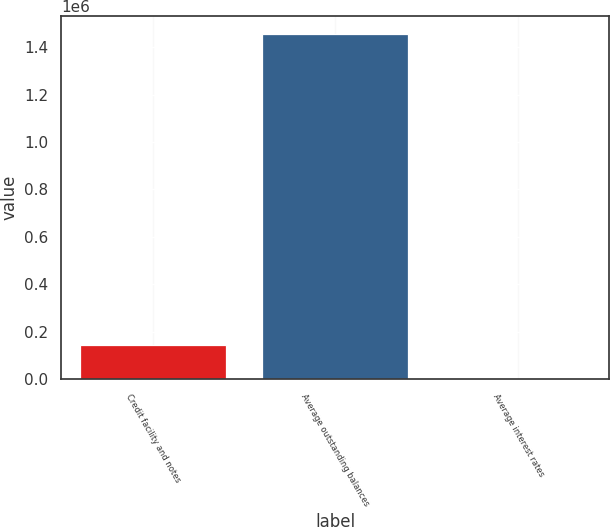Convert chart. <chart><loc_0><loc_0><loc_500><loc_500><bar_chart><fcel>Credit facility and notes<fcel>Average outstanding balances<fcel>Average interest rates<nl><fcel>145728<fcel>1.45722e+06<fcel>6.26<nl></chart> 